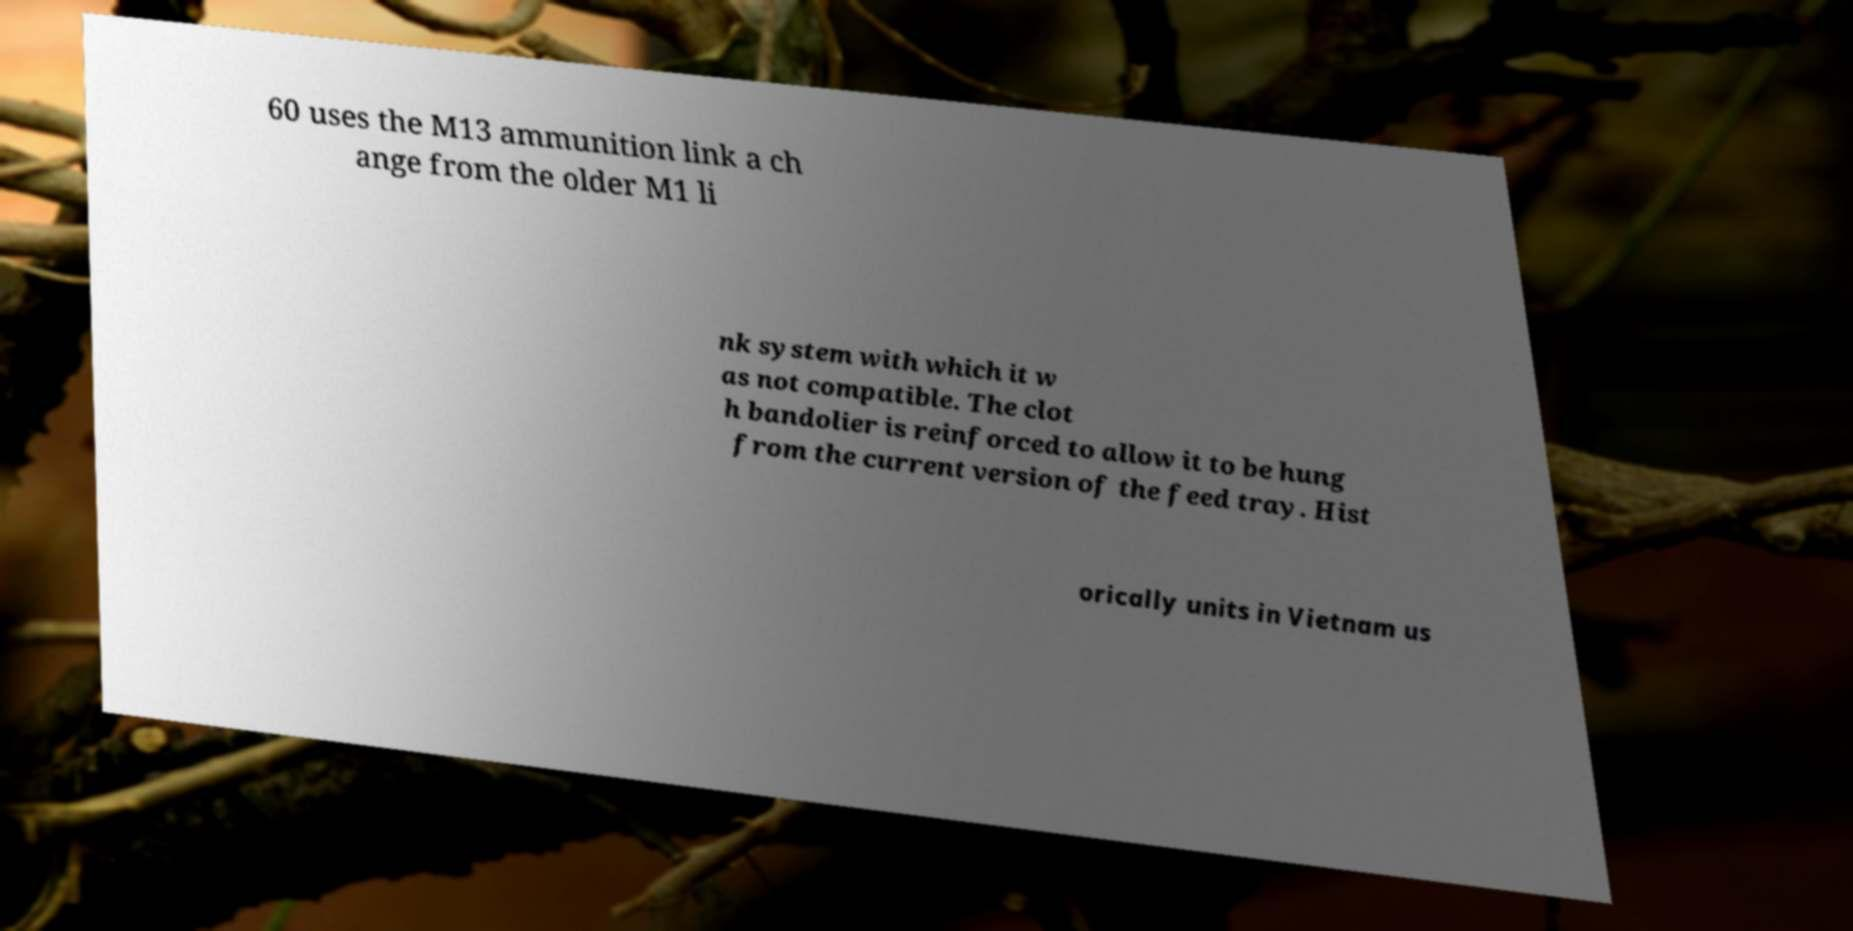There's text embedded in this image that I need extracted. Can you transcribe it verbatim? 60 uses the M13 ammunition link a ch ange from the older M1 li nk system with which it w as not compatible. The clot h bandolier is reinforced to allow it to be hung from the current version of the feed tray. Hist orically units in Vietnam us 